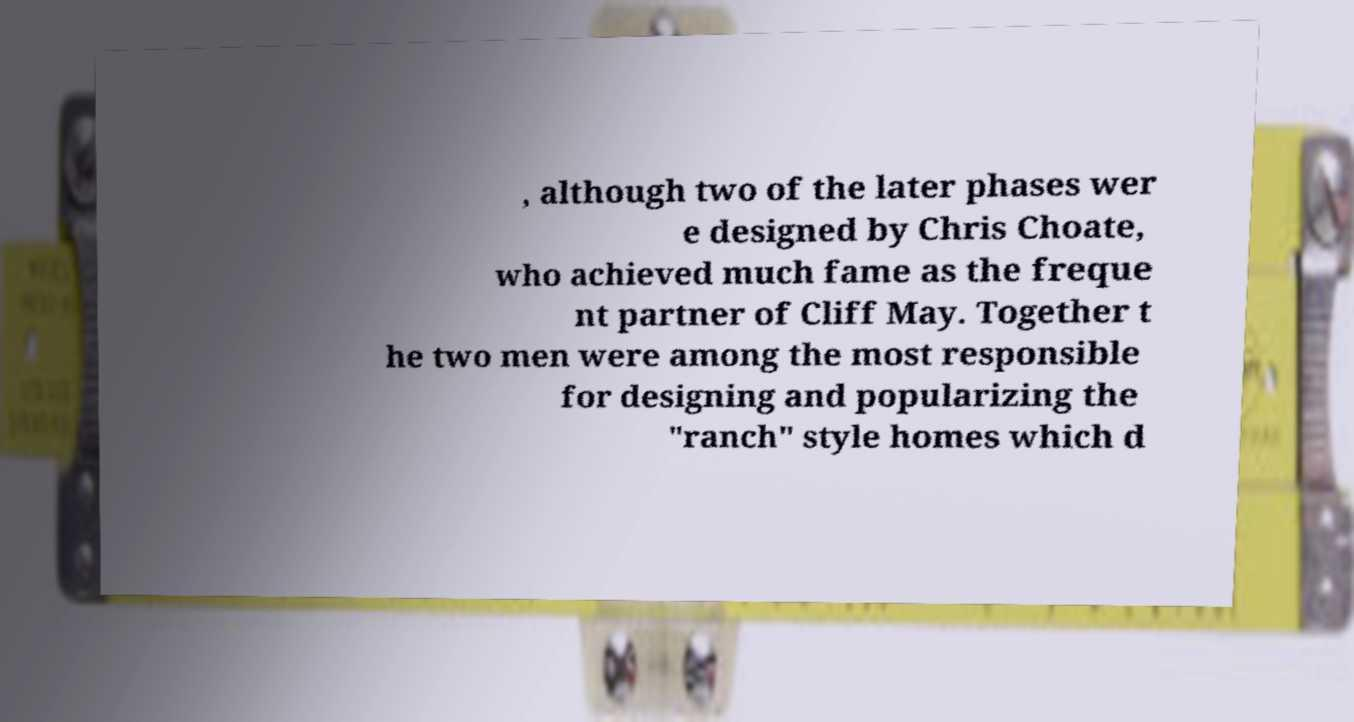Please identify and transcribe the text found in this image. , although two of the later phases wer e designed by Chris Choate, who achieved much fame as the freque nt partner of Cliff May. Together t he two men were among the most responsible for designing and popularizing the "ranch" style homes which d 